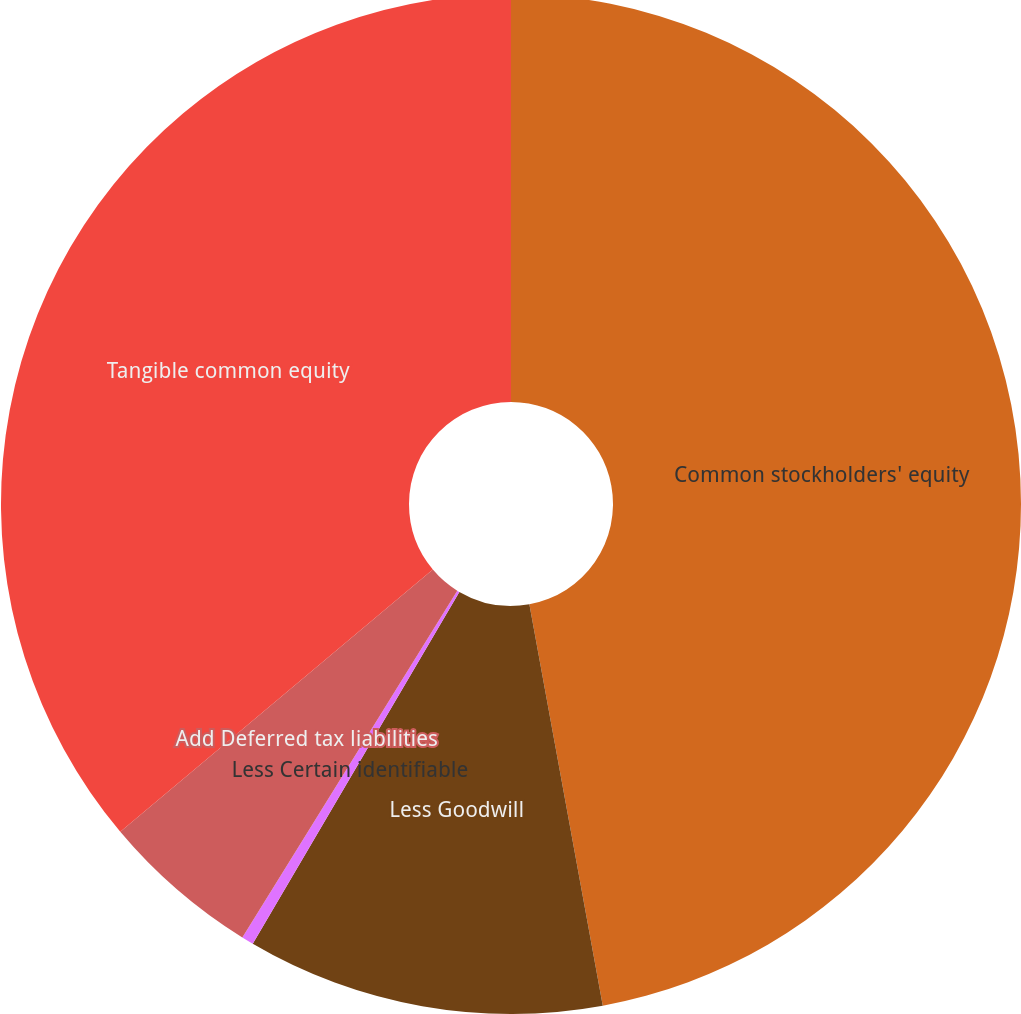Convert chart to OTSL. <chart><loc_0><loc_0><loc_500><loc_500><pie_chart><fcel>Common stockholders' equity<fcel>Less Goodwill<fcel>Less Certain identifiable<fcel>Add Deferred tax liabilities<fcel>Tangible common equity<nl><fcel>47.12%<fcel>11.33%<fcel>0.38%<fcel>5.06%<fcel>36.11%<nl></chart> 